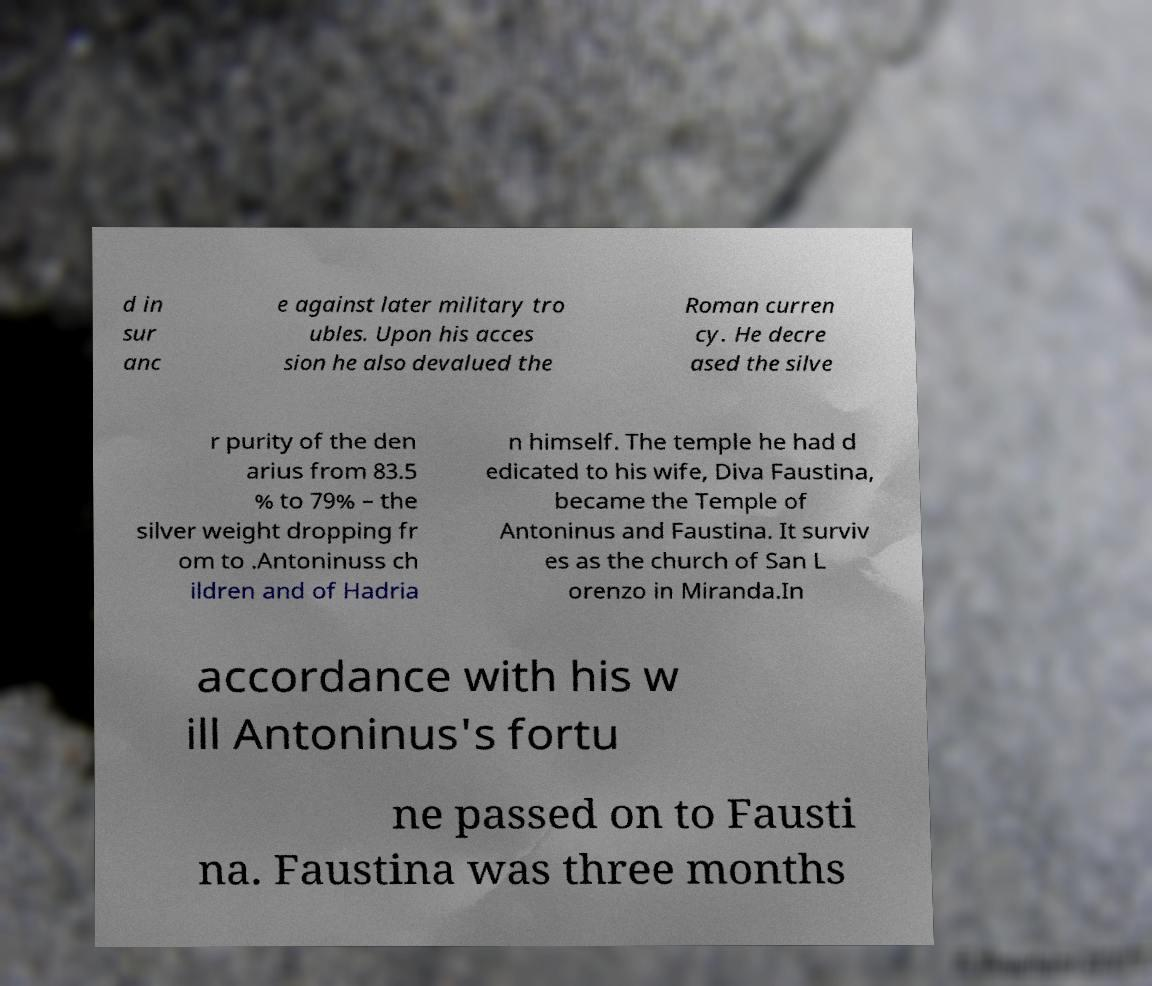Can you read and provide the text displayed in the image?This photo seems to have some interesting text. Can you extract and type it out for me? d in sur anc e against later military tro ubles. Upon his acces sion he also devalued the Roman curren cy. He decre ased the silve r purity of the den arius from 83.5 % to 79% – the silver weight dropping fr om to .Antoninuss ch ildren and of Hadria n himself. The temple he had d edicated to his wife, Diva Faustina, became the Temple of Antoninus and Faustina. It surviv es as the church of San L orenzo in Miranda.In accordance with his w ill Antoninus's fortu ne passed on to Fausti na. Faustina was three months 